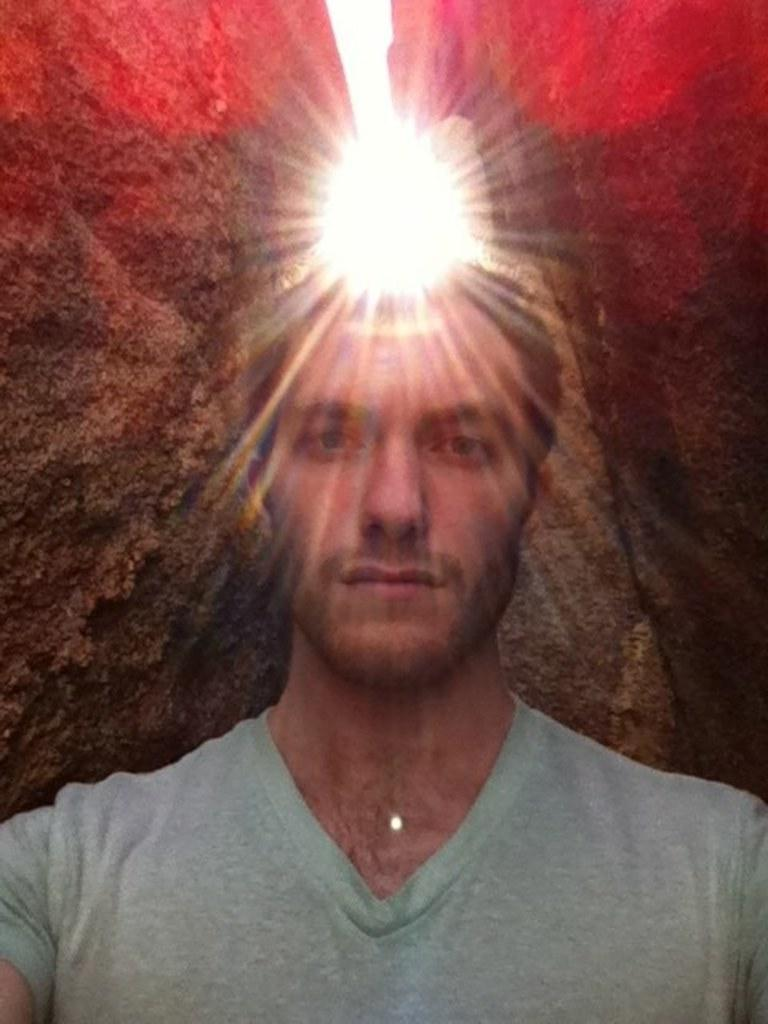Who is present in the image? There is a man in the image. What is the man wearing? The man is wearing a t-shirt. Can you describe any other elements in the image? There is a light visible in the image. What type of berry is the man holding in the image? There is no berry present in the image; the man is not holding anything. Can you describe the flock of birds in the image? There are no birds or flocks present in the image. 